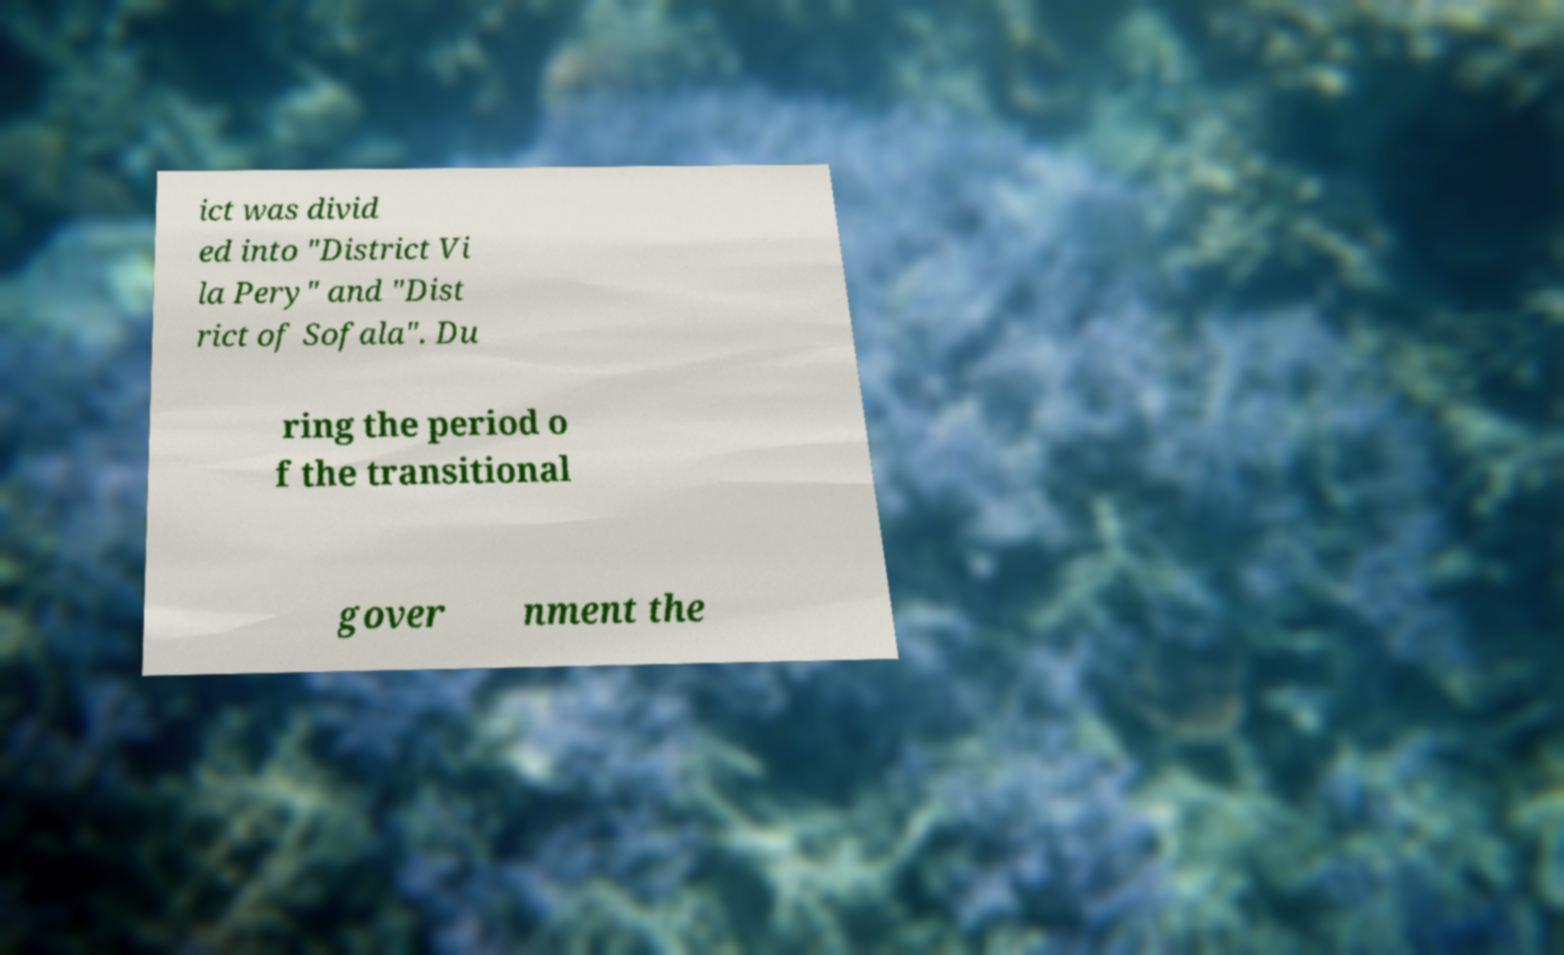Please identify and transcribe the text found in this image. ict was divid ed into "District Vi la Pery" and "Dist rict of Sofala". Du ring the period o f the transitional gover nment the 